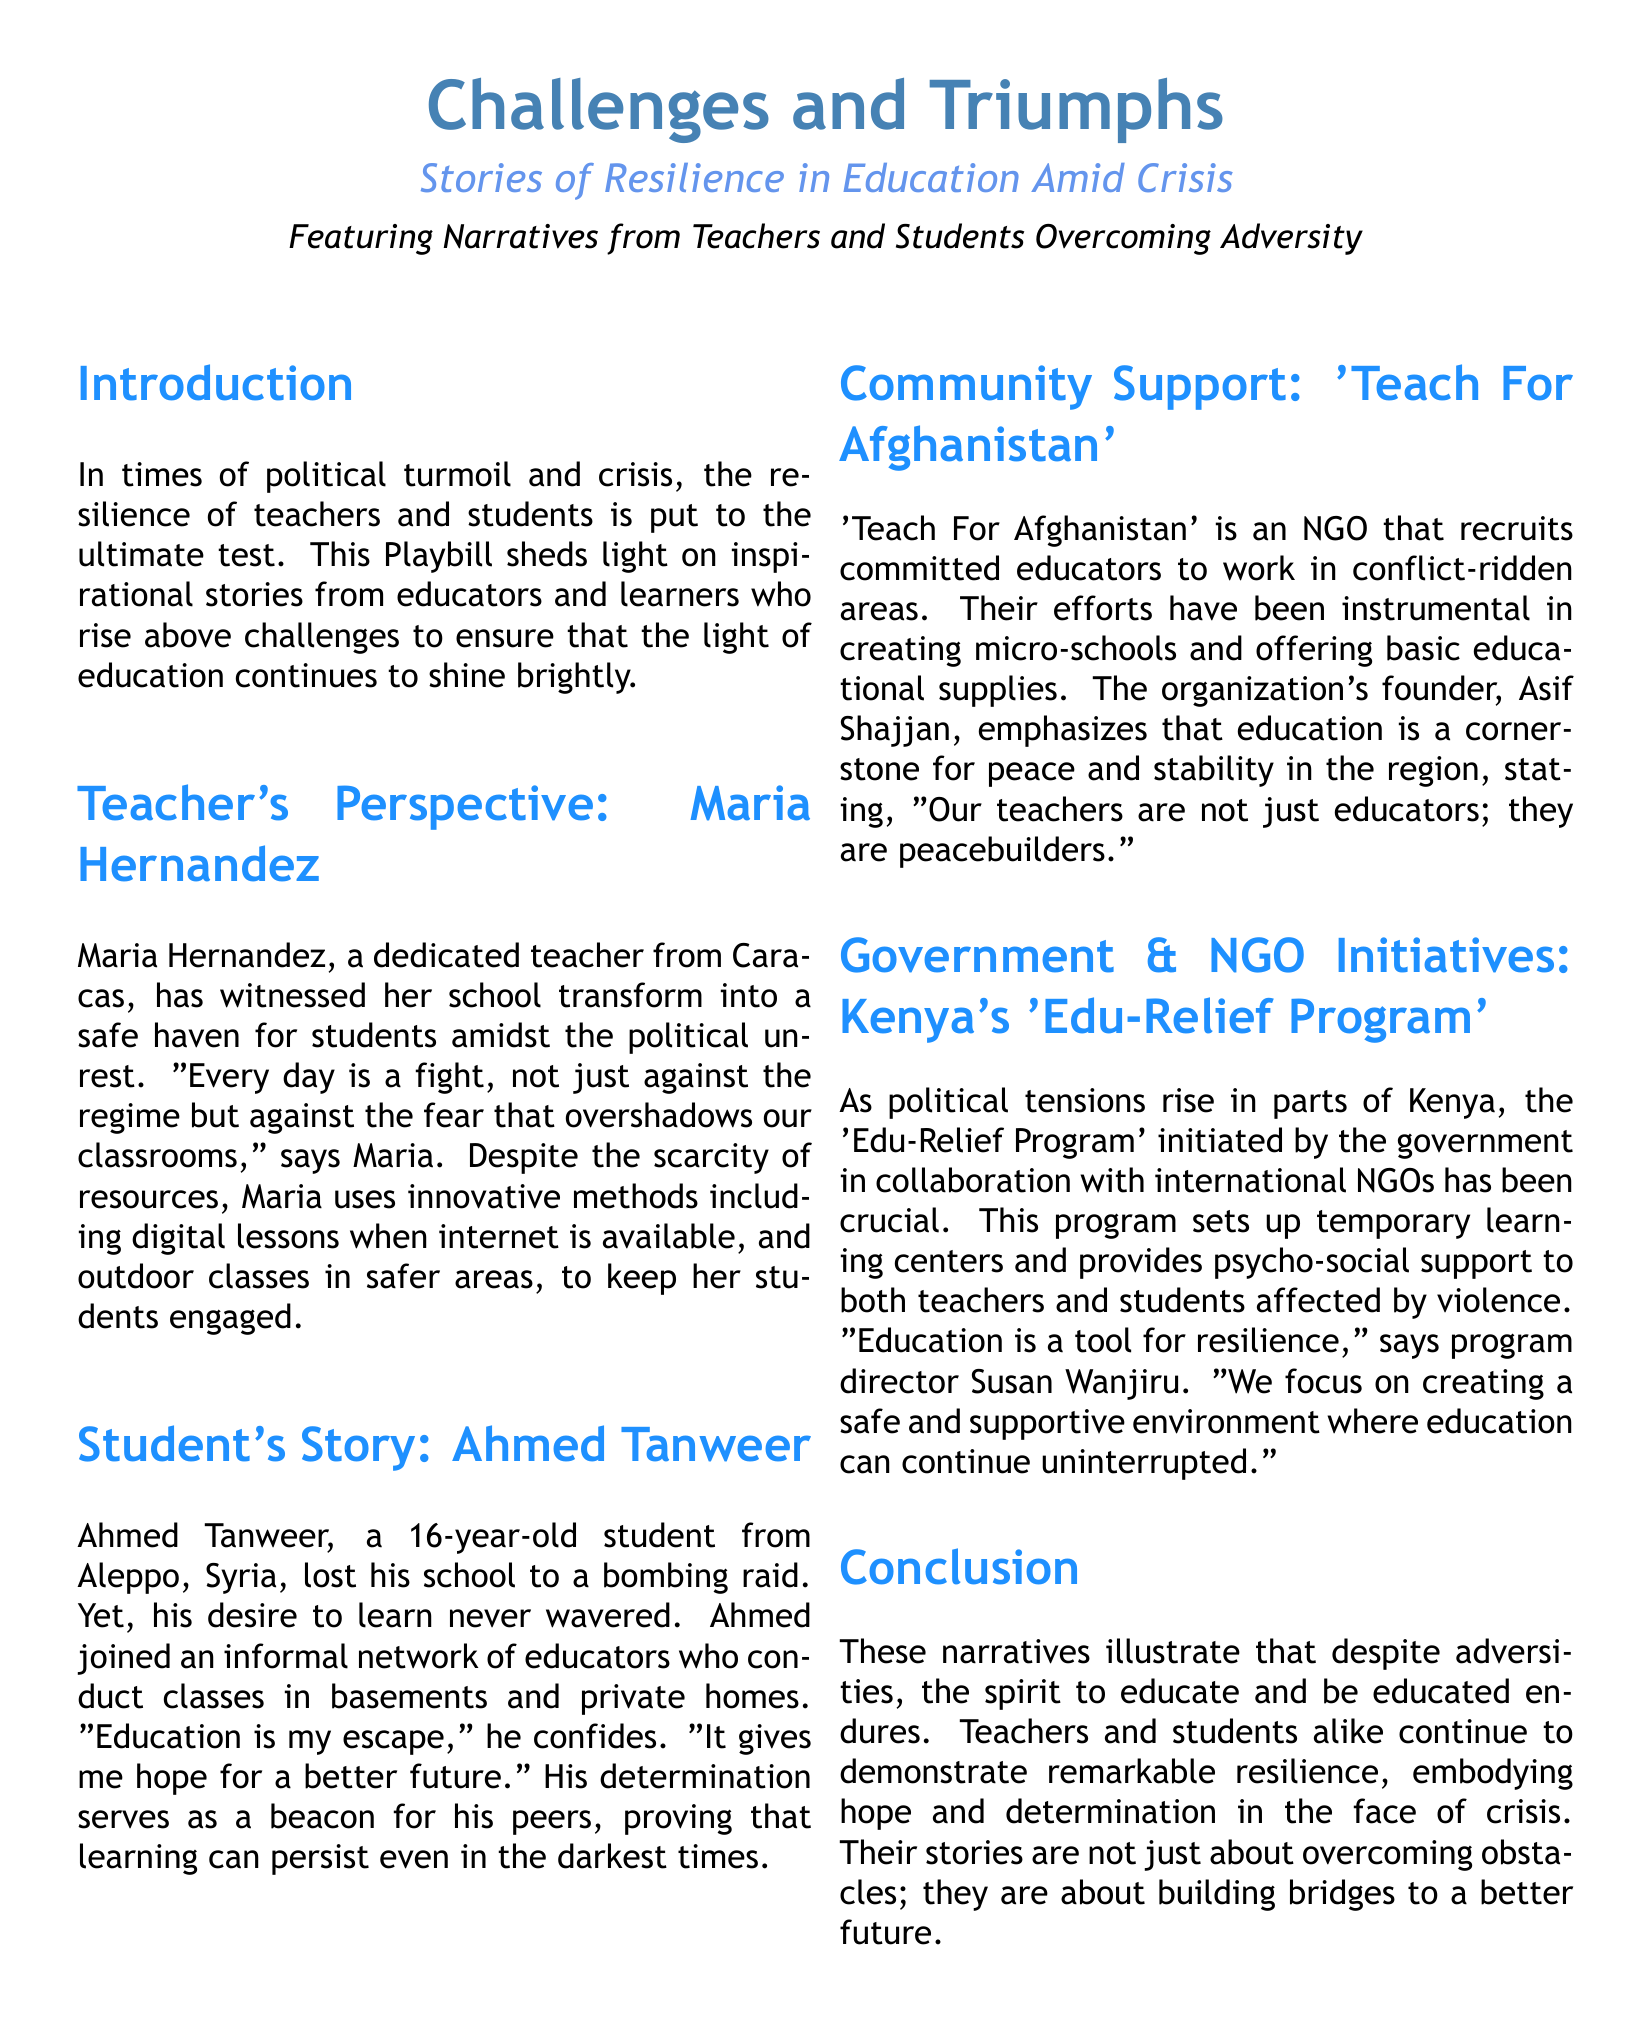What is the title of the Playbill? The title of the Playbill is mentioned in large text at the beginning of the document.
Answer: Challenges and Triumphs Who is the teacher featured in the Playbill? The document mentions a teacher's story and includes her name and location.
Answer: Maria Hernandez What city does Ahmed Tanweer come from? The city of Ahmed Tanweer is stated in his narrative.
Answer: Aleppo What organization is mentioned in relation to education in Afghanistan? The document highlights an NGO working in conflict-ridden areas in Afghanistan.
Answer: Teach For Afghanistan What does Susan Wanjiru emphasize about education in her quote? Susan Wanjiru's statement covers the role of education under difficult circumstances.
Answer: A tool for resilience How does Maria Hernandez adapt to the lack of resources? The document describes specific methods used by Maria Hernandez to educate her students.
Answer: Innovative methods What type of centers does the 'Edu-Relief Program' set up? The document describes the type of support provided by the 'Edu-Relief Program'.
Answer: Temporary learning centers What role do teachers play according to Asif Shajjan? The document highlights the dual role of teachers as per the organization's founder.
Answer: Peacebuilders How many perspectives are featured in the document? The document counts the different narratives included in the Playbill.
Answer: Multiple perspectives 